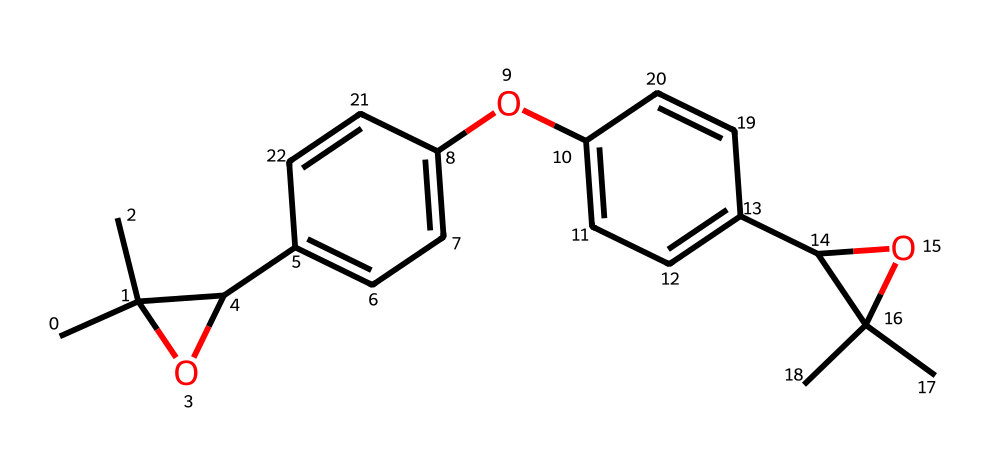What is the molecular formula of this photoresist? By analyzing the SMILES representation, we can identify that there are 24 carbons, 30 hydrogens, and 4 oxygens. Thus, the molecular formula can be derived as C24H30O4.
Answer: C24H30O4 How many rings are present in the structure? Observing the SMILES, the notation indicates the presence of two distinct ring structures: one in the form of a simple cyclic ether (the part with 'C1(C)O' which denotes a cyclic structure), and the other is part of the aromatic systems, indicating that there are two rings.
Answer: 2 What type of chemical structure is this? The structure is complex and contains aryl groups and ether linkages, identifying it as an organic compound specific to the class of polymers used for photoresists.
Answer: organic compound Which functional groups are evident in this structure? In the structure, there are ether (indicated by 'O' within two carbons) and hydroxyl (indicated by 'OH') functional groups. Both of these functionalities influence the chemical's properties significantly.
Answer: ether and hydroxyl What is the significance of the hydroxyl group in this photoresist? The hydroxyl group enhances the solubility of the photoresist in certain solvents and also provides sites for potential chemical reactions during processing, which is crucial for microfluidic applications.
Answer: solubility and reactivity Which part of the molecule is likely responsible for its photosensitivity? The aromatic rings (represented in the structure) generally absorb light and are often functionalized to create photoactive species, making them key in the photosensitivity of photoresists.
Answer: aromatic rings 